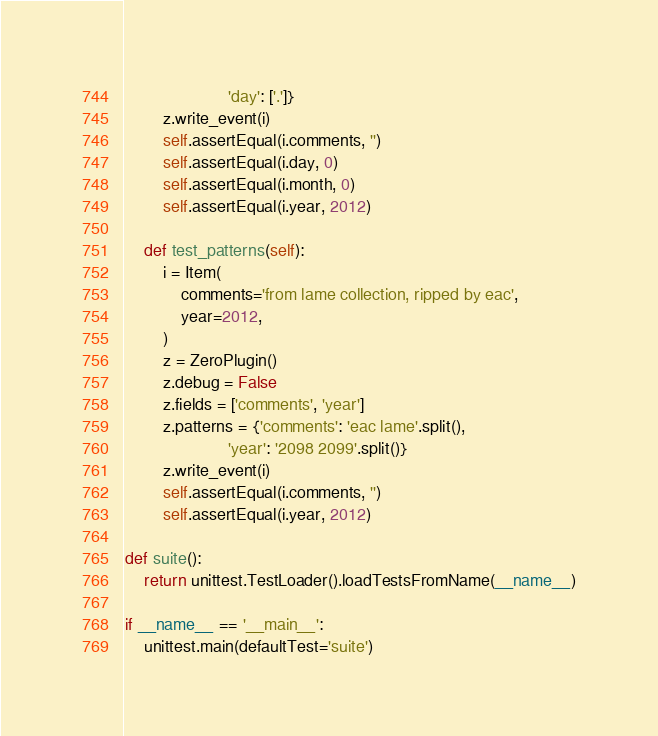<code> <loc_0><loc_0><loc_500><loc_500><_Python_>                      'day': ['.']}
        z.write_event(i)
        self.assertEqual(i.comments, '')
        self.assertEqual(i.day, 0)
        self.assertEqual(i.month, 0)
        self.assertEqual(i.year, 2012)

    def test_patterns(self):
        i = Item(
            comments='from lame collection, ripped by eac',
            year=2012,
        )
        z = ZeroPlugin()
        z.debug = False
        z.fields = ['comments', 'year']
        z.patterns = {'comments': 'eac lame'.split(),
                      'year': '2098 2099'.split()}
        z.write_event(i)
        self.assertEqual(i.comments, '')
        self.assertEqual(i.year, 2012)

def suite():
    return unittest.TestLoader().loadTestsFromName(__name__)

if __name__ == '__main__':
    unittest.main(defaultTest='suite')
</code> 